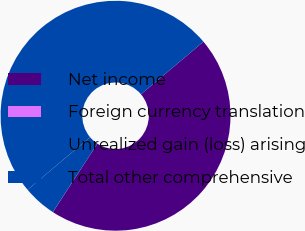<chart> <loc_0><loc_0><loc_500><loc_500><pie_chart><fcel>Net income<fcel>Foreign currency translation<fcel>Unrealized gain (loss) arising<fcel>Total other comprehensive<nl><fcel>45.32%<fcel>0.01%<fcel>4.68%<fcel>49.99%<nl></chart> 